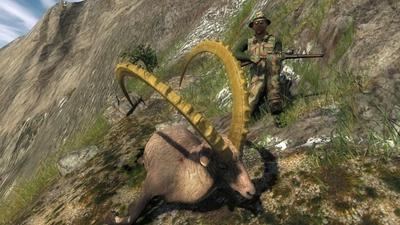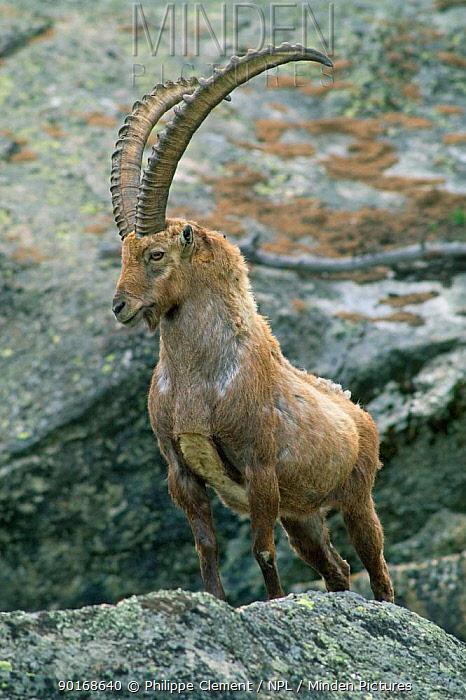The first image is the image on the left, the second image is the image on the right. Given the left and right images, does the statement "There is a total of four animals." hold true? Answer yes or no. No. 